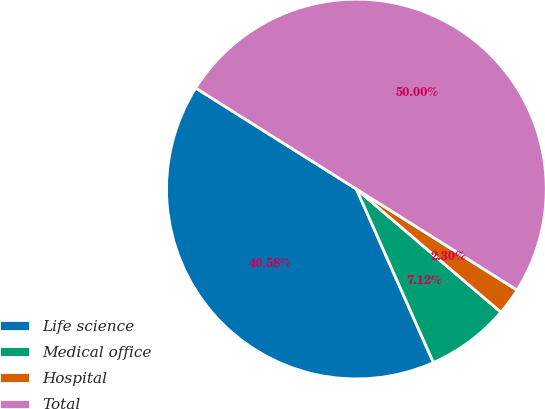<chart> <loc_0><loc_0><loc_500><loc_500><pie_chart><fcel>Life science<fcel>Medical office<fcel>Hospital<fcel>Total<nl><fcel>40.58%<fcel>7.12%<fcel>2.3%<fcel>50.0%<nl></chart> 